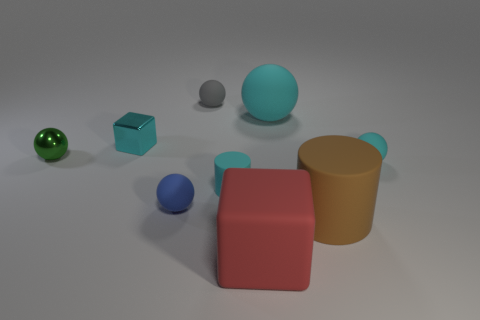What textures can you see on the objects in the image? The objects exhibit a variety of textures. The large red block and the yellow cup have a matte finish, while the green sphere, blue metallic block, and smaller blue sphere have a reflective or shiny surface. 